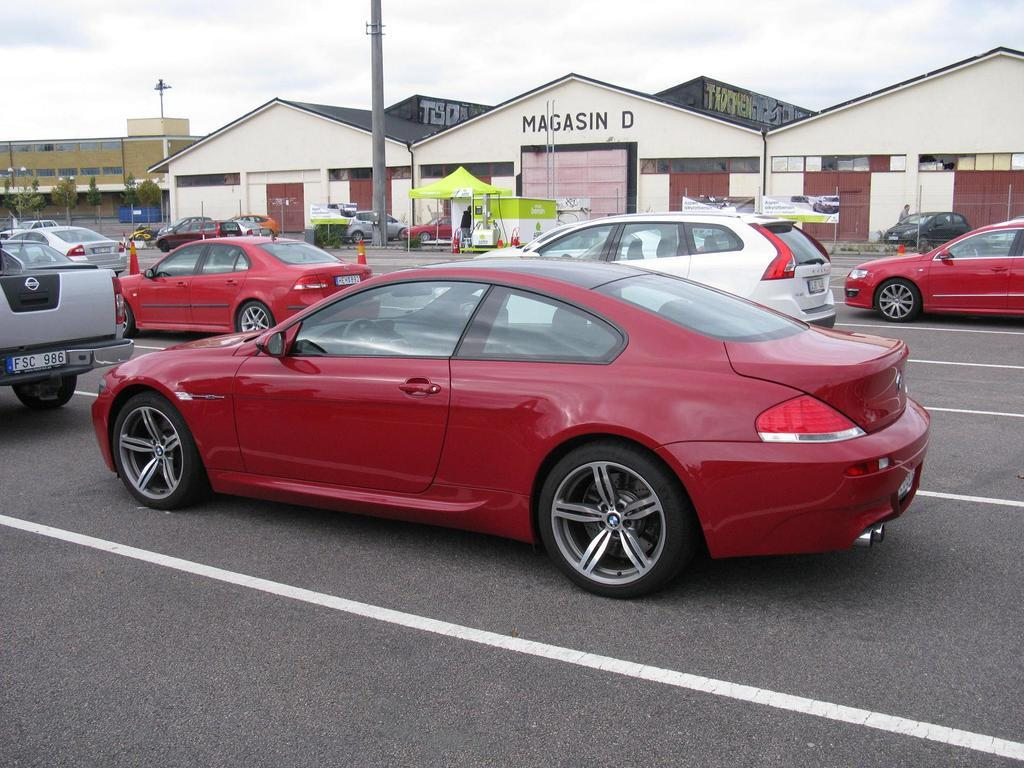What can be seen on the road in the image? There are vehicles on the road in the image. What is visible in the background of the image? There are buildings, poles, a stall, objects on the ground, trees, and the sky visible in the background of the image. What type of steam is coming out of the hospital in the image? There is no hospital present in the image, so there is no steam to be observed. 